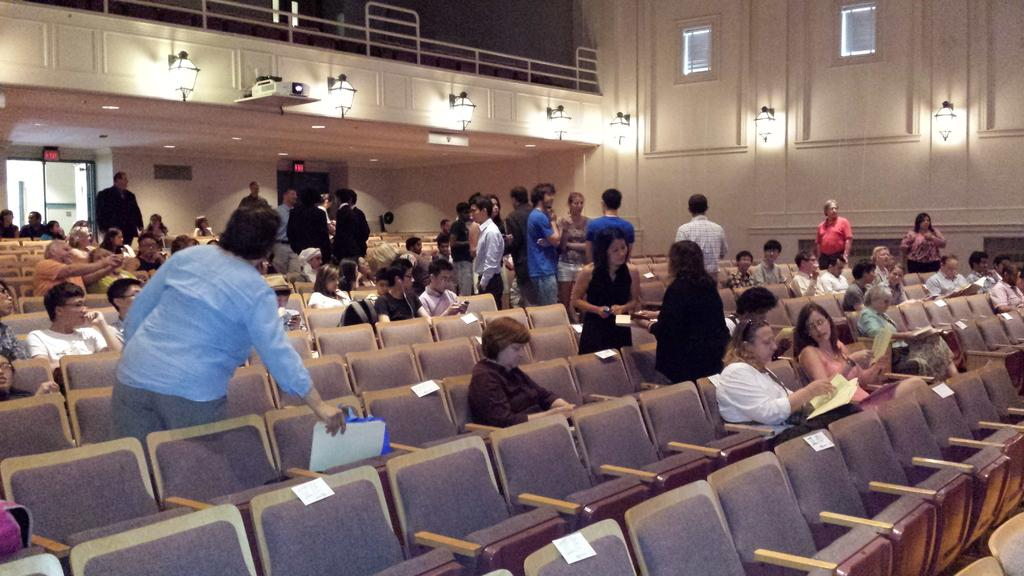What are the persons in the image doing? The persons in the image are sitting and standing at chairs. Can you describe the background of the image? In the background of the image, there are lights, a door, windows, and a wall. How many elements can be seen in the background of the image? There are five elements visible in the background: lights, a door, windows, and a wall. What type of flag is being waved by the persons in the image? There is no flag present in the image; the persons are sitting and standing at chairs. What part of the human body is visible in the image? The image does not show any flesh or body parts; it only shows persons sitting and standing at chairs and the background elements. 